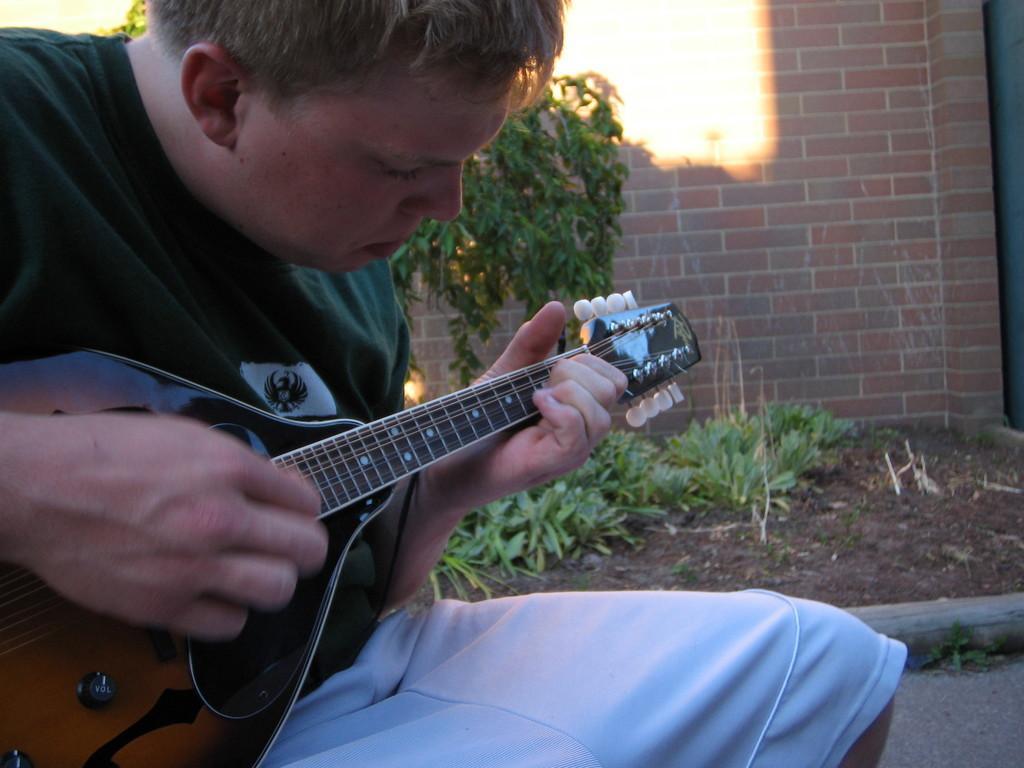How would you summarize this image in a sentence or two? In the image we can see there is a person who is sitting and holding a guitar in his hand and at the back there is a wall which is made up of red bricks. 